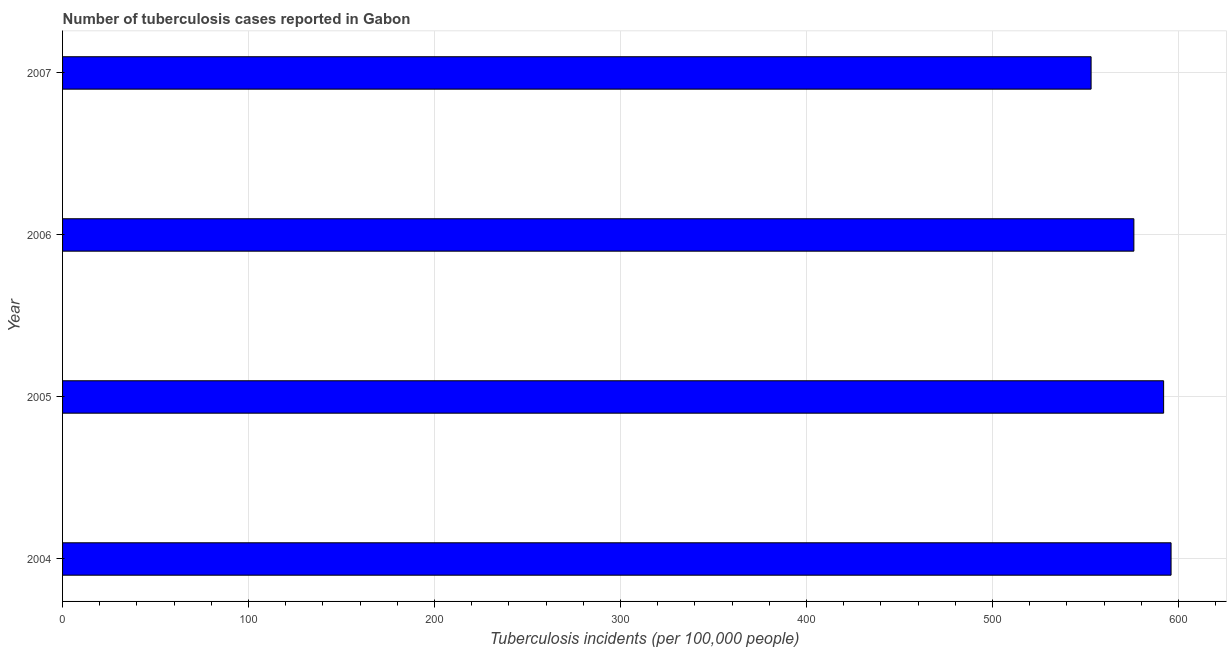What is the title of the graph?
Your answer should be compact. Number of tuberculosis cases reported in Gabon. What is the label or title of the X-axis?
Provide a succinct answer. Tuberculosis incidents (per 100,0 people). What is the number of tuberculosis incidents in 2005?
Make the answer very short. 592. Across all years, what is the maximum number of tuberculosis incidents?
Provide a succinct answer. 596. Across all years, what is the minimum number of tuberculosis incidents?
Keep it short and to the point. 553. In which year was the number of tuberculosis incidents maximum?
Make the answer very short. 2004. In which year was the number of tuberculosis incidents minimum?
Your answer should be compact. 2007. What is the sum of the number of tuberculosis incidents?
Provide a short and direct response. 2317. What is the difference between the number of tuberculosis incidents in 2004 and 2006?
Give a very brief answer. 20. What is the average number of tuberculosis incidents per year?
Provide a succinct answer. 579. What is the median number of tuberculosis incidents?
Keep it short and to the point. 584. In how many years, is the number of tuberculosis incidents greater than 340 ?
Your answer should be compact. 4. What is the ratio of the number of tuberculosis incidents in 2004 to that in 2006?
Your response must be concise. 1.03. Is the number of tuberculosis incidents in 2004 less than that in 2005?
Make the answer very short. No. What is the difference between the highest and the second highest number of tuberculosis incidents?
Your answer should be compact. 4. Is the sum of the number of tuberculosis incidents in 2004 and 2006 greater than the maximum number of tuberculosis incidents across all years?
Offer a very short reply. Yes. What is the difference between the highest and the lowest number of tuberculosis incidents?
Offer a terse response. 43. How many years are there in the graph?
Provide a short and direct response. 4. What is the difference between two consecutive major ticks on the X-axis?
Offer a terse response. 100. What is the Tuberculosis incidents (per 100,000 people) of 2004?
Offer a terse response. 596. What is the Tuberculosis incidents (per 100,000 people) in 2005?
Your answer should be compact. 592. What is the Tuberculosis incidents (per 100,000 people) of 2006?
Keep it short and to the point. 576. What is the Tuberculosis incidents (per 100,000 people) of 2007?
Your answer should be very brief. 553. What is the difference between the Tuberculosis incidents (per 100,000 people) in 2004 and 2005?
Offer a very short reply. 4. What is the difference between the Tuberculosis incidents (per 100,000 people) in 2004 and 2006?
Offer a terse response. 20. What is the difference between the Tuberculosis incidents (per 100,000 people) in 2005 and 2006?
Your response must be concise. 16. What is the difference between the Tuberculosis incidents (per 100,000 people) in 2006 and 2007?
Your answer should be very brief. 23. What is the ratio of the Tuberculosis incidents (per 100,000 people) in 2004 to that in 2006?
Provide a succinct answer. 1.03. What is the ratio of the Tuberculosis incidents (per 100,000 people) in 2004 to that in 2007?
Keep it short and to the point. 1.08. What is the ratio of the Tuberculosis incidents (per 100,000 people) in 2005 to that in 2006?
Offer a very short reply. 1.03. What is the ratio of the Tuberculosis incidents (per 100,000 people) in 2005 to that in 2007?
Make the answer very short. 1.07. What is the ratio of the Tuberculosis incidents (per 100,000 people) in 2006 to that in 2007?
Your response must be concise. 1.04. 